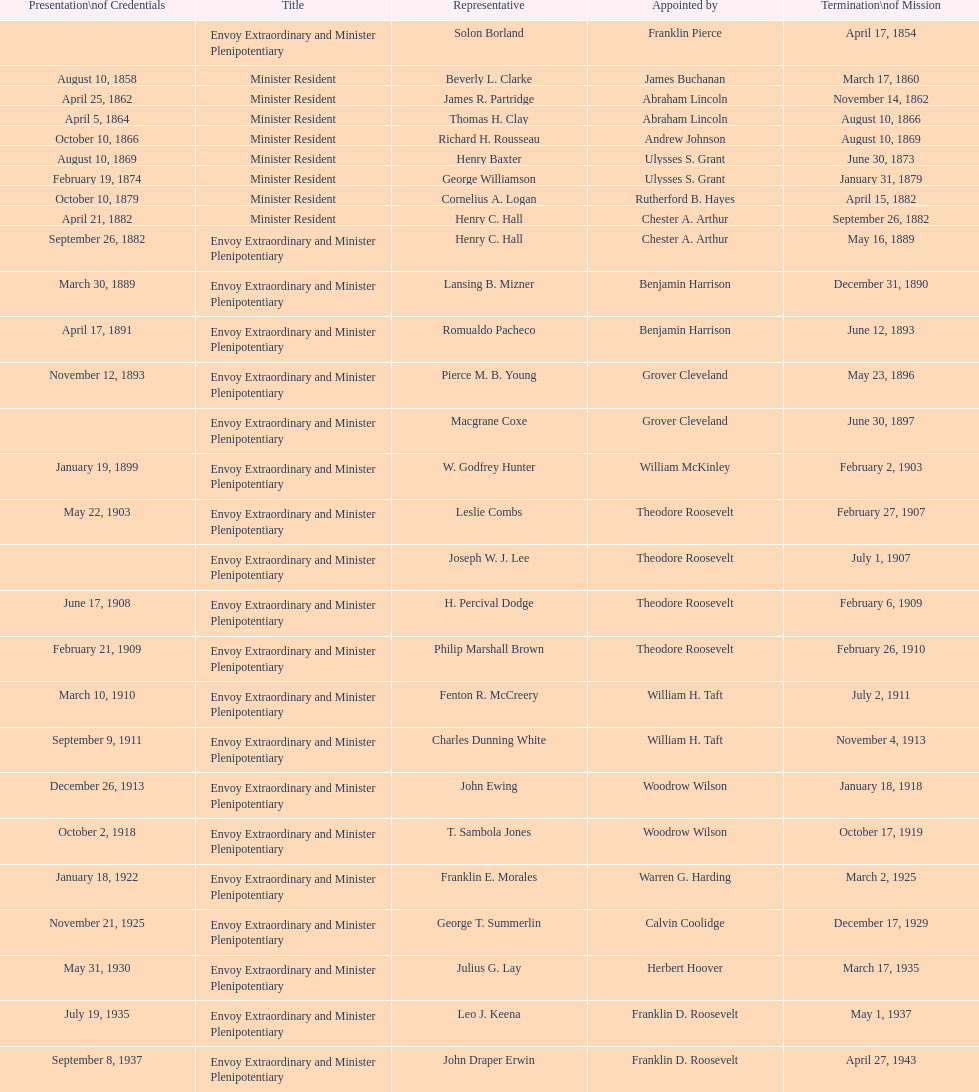After the culmination of hewson ryan's mission, who took on the role of ambassador? Phillip V. Sanchez. 